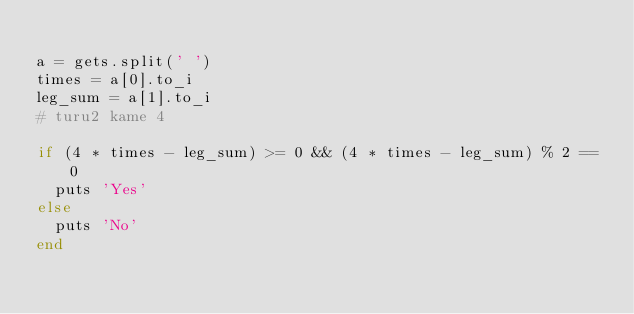<code> <loc_0><loc_0><loc_500><loc_500><_Ruby_>
a = gets.split(' ')
times = a[0].to_i
leg_sum = a[1].to_i
# turu2 kame 4

if (4 * times - leg_sum) >= 0 && (4 * times - leg_sum) % 2 == 0
  puts 'Yes'
else
  puts 'No'
end</code> 